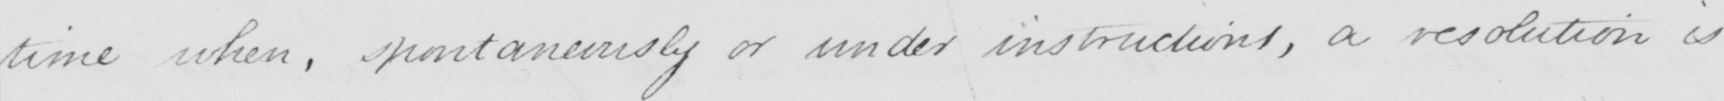What does this handwritten line say? time when , spontaneously or under instructions , a resolution is 